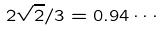<formula> <loc_0><loc_0><loc_500><loc_500>2 \sqrt { 2 } / 3 = 0 . 9 4 \cdots</formula> 